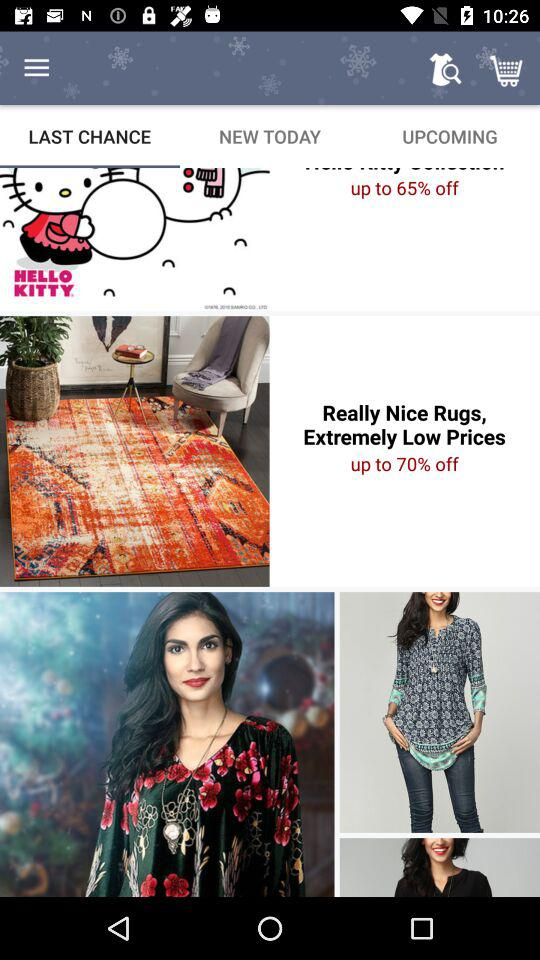How many items have a discount greater than 50%?
Answer the question using a single word or phrase. 2 